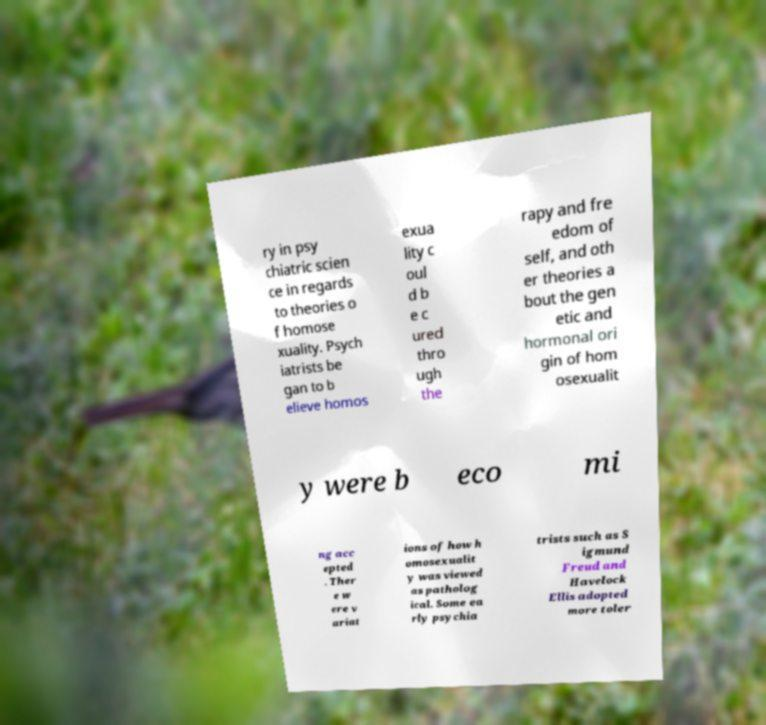Can you accurately transcribe the text from the provided image for me? ry in psy chiatric scien ce in regards to theories o f homose xuality. Psych iatrists be gan to b elieve homos exua lity c oul d b e c ured thro ugh the rapy and fre edom of self, and oth er theories a bout the gen etic and hormonal ori gin of hom osexualit y were b eco mi ng acc epted . Ther e w ere v ariat ions of how h omosexualit y was viewed as patholog ical. Some ea rly psychia trists such as S igmund Freud and Havelock Ellis adopted more toler 